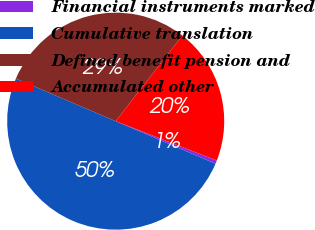Convert chart. <chart><loc_0><loc_0><loc_500><loc_500><pie_chart><fcel>Financial instruments marked<fcel>Cumulative translation<fcel>Defined benefit pension and<fcel>Accumulated other<nl><fcel>0.51%<fcel>50.0%<fcel>29.1%<fcel>20.39%<nl></chart> 